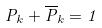<formula> <loc_0><loc_0><loc_500><loc_500>P _ { k } + \overline { P } _ { k } = 1</formula> 